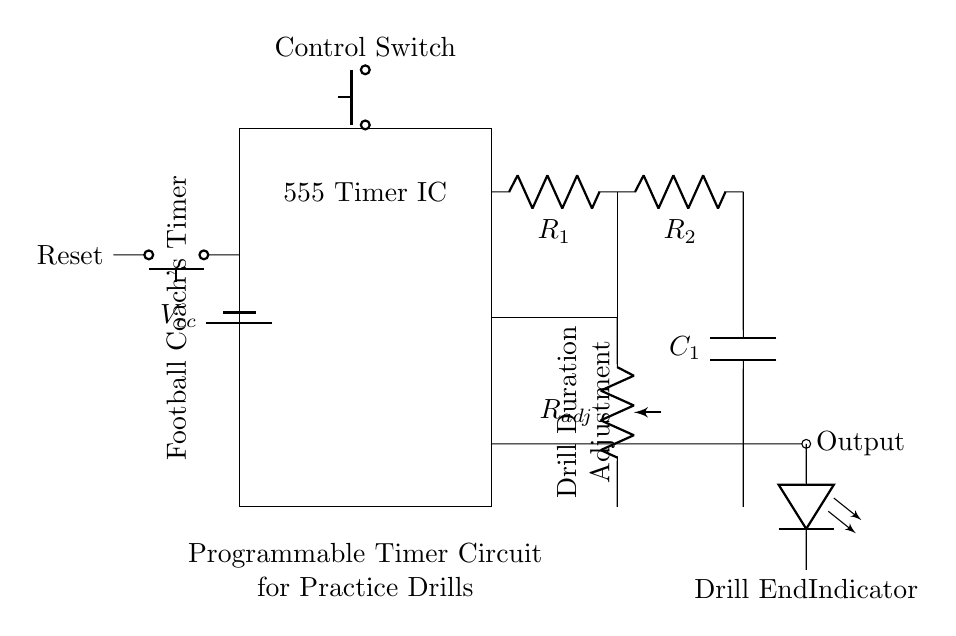What is the main component used in this circuit? The main component is the 555 Timer IC, which is used to create a programmable timing function for the circuit.
Answer: 555 Timer IC What does the control switch do? The control switch, labeled as "Control Switch," is used to initiate or reset the timer, allowing the coach to start or stop a drill.
Answer: Start/Stop Which component indicates when the drill is finished? The LED indicator is connected to the output of the timer and lights up to signal that the drill has ended.
Answer: LED How can the drill duration be adjusted? The drill duration can be adjusted using the potentiometer labeled "R adj," which changes the resistance and thus alters the timing interval of the timer.
Answer: Potentiometer What is the voltage supply for this circuit? The circuit is supplied with a voltage from a battery labeled as "V cc," providing the necessary power for the timer and other components.
Answer: V cc Which components are in series with the timer? The resistors R1 and R2 are in series with the capacitor C1, creating the timing circuit that determines the duration of the drills.
Answer: R1, R2, C1 What function does the reset button serve? The reset button allows the coach to reset the timer back to its initial state, ensuring that the next drill can start from zero without carrying over any previous timing.
Answer: Reset 